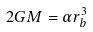Convert formula to latex. <formula><loc_0><loc_0><loc_500><loc_500>2 G M = \alpha r _ { b } ^ { 3 }</formula> 